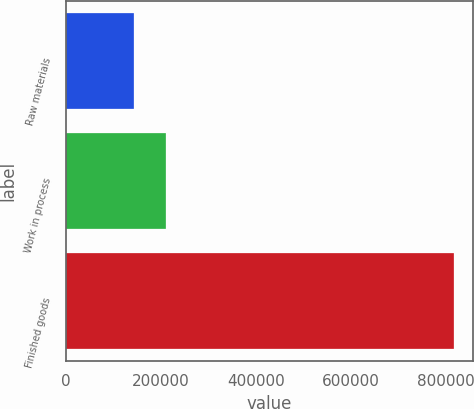Convert chart. <chart><loc_0><loc_0><loc_500><loc_500><bar_chart><fcel>Raw materials<fcel>Work in process<fcel>Finished goods<nl><fcel>143430<fcel>210844<fcel>817570<nl></chart> 